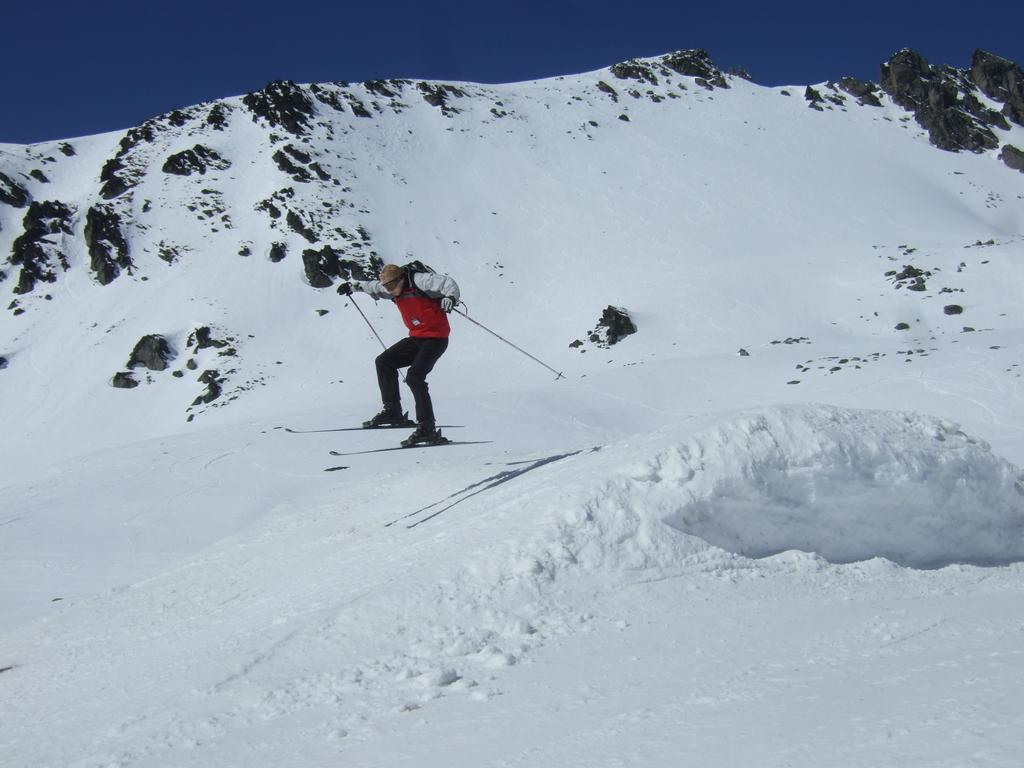What activity is the person in the image engaged in? The person is skiing in the image. What equipment is the person using for skiing? The person is using ski boards and holding sticks in their hands. What type of terrain is visible in the image? There is snow in the image. What can be seen in the background of the image? The sky is visible in the background of the image. What type of bun is the person eating while skiing in the image? There is no bun present in the image; the person is skiing and holding sticks in their hands. 